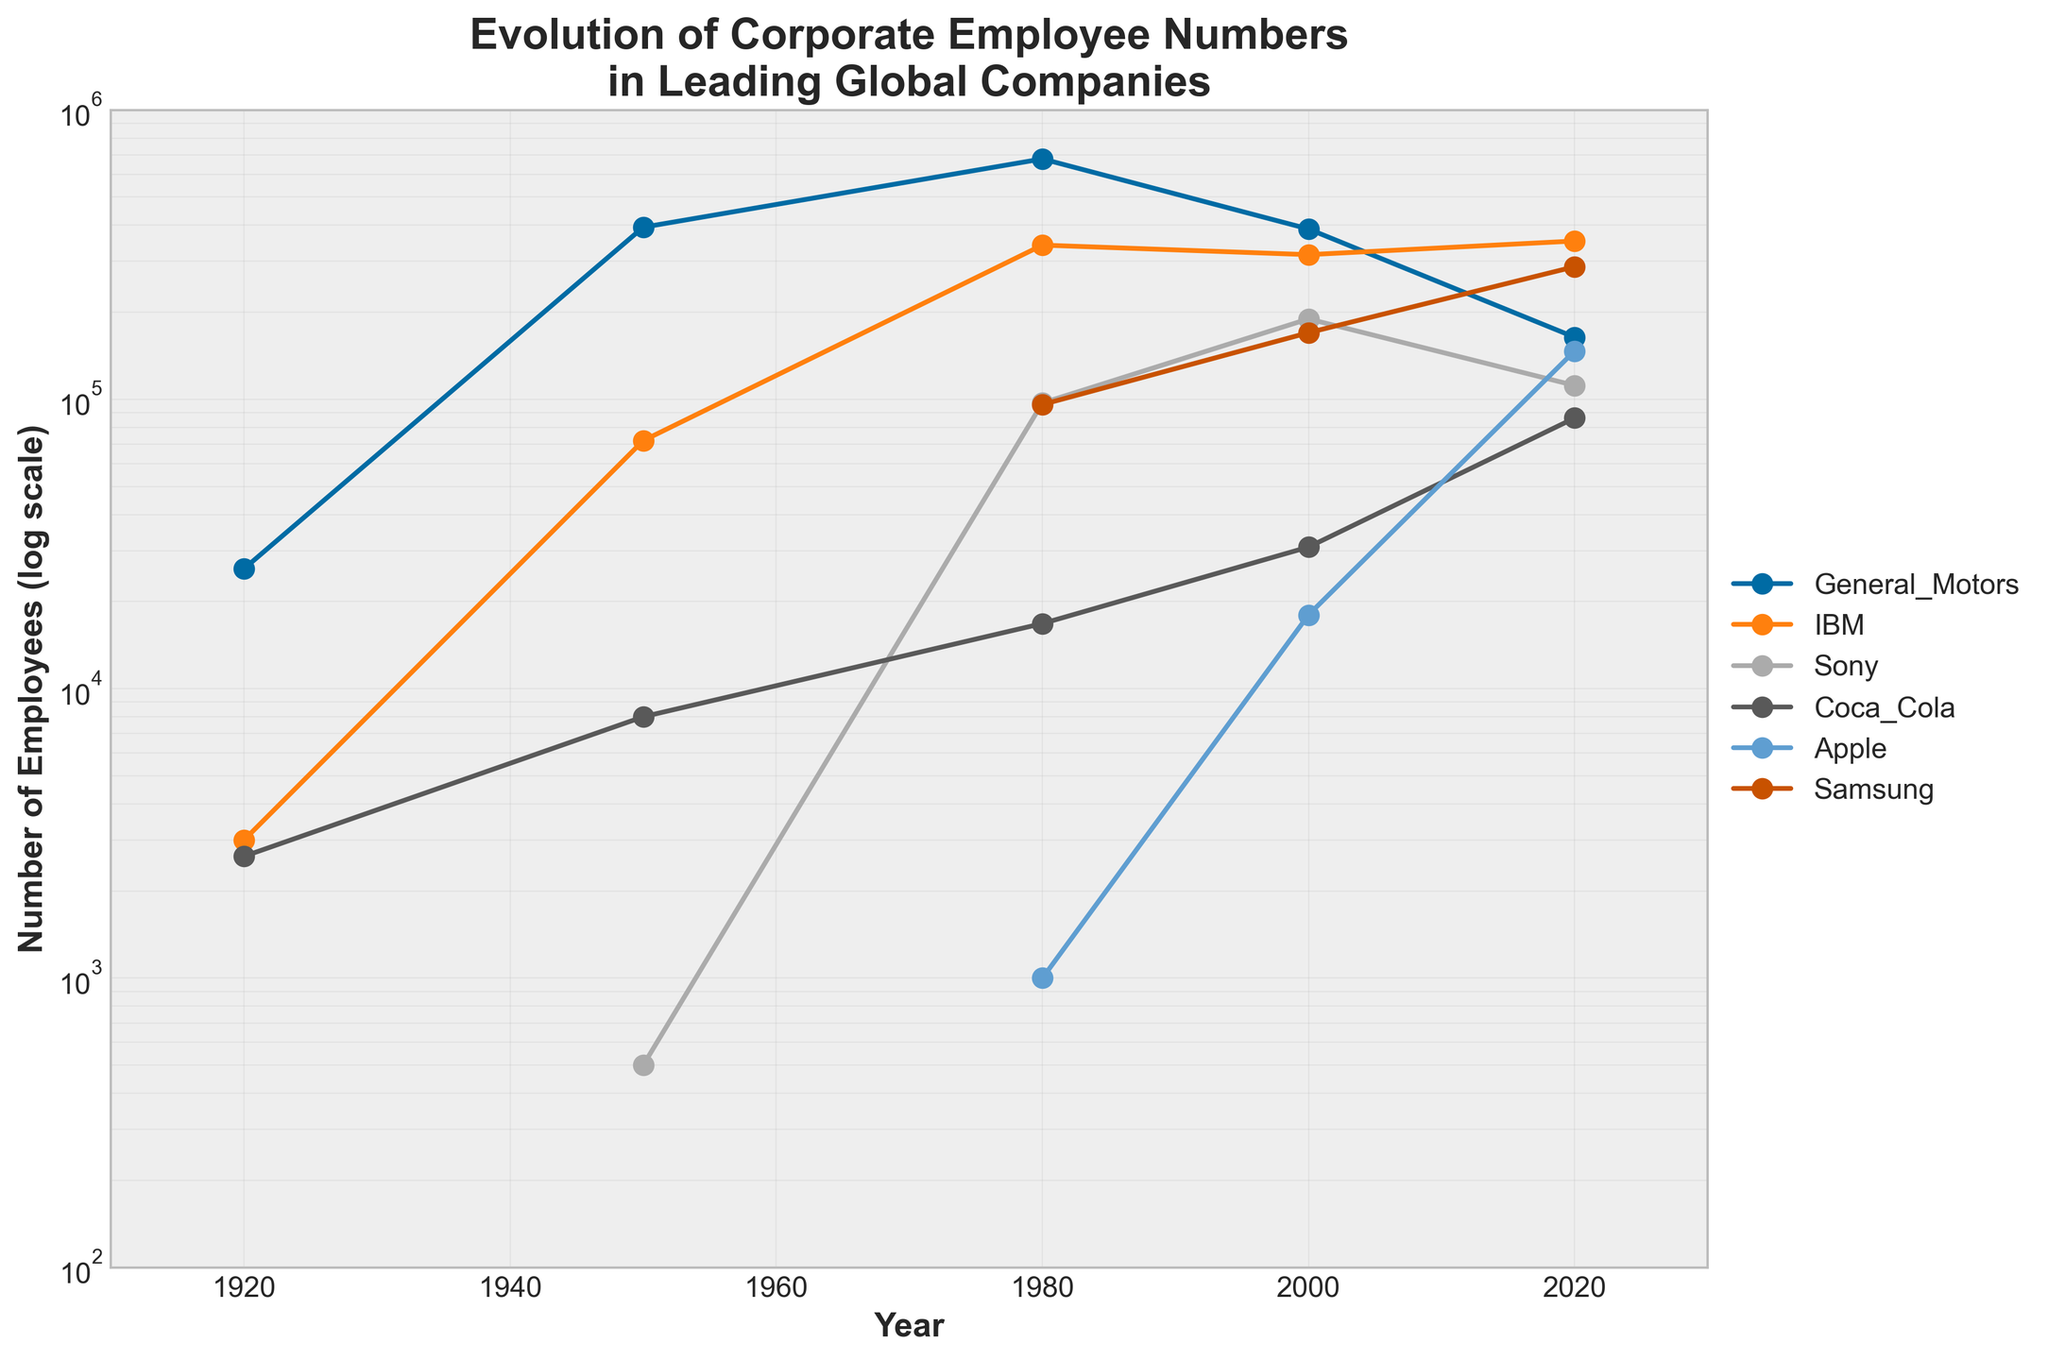How many companies are shown in the figure? By counting the different labels in the legend (like General Motors, IBM, Sony, etc.), we can identify the number of companies represented.
Answer: 6 What is the title of the figure? The title is typically located at the top of the figure and provides an overview of what the figure represents.
Answer: Evolution of Corporate Employee Numbers in Leading Global Companies What is the highest number of employees for Samsung according to the figure? We trace the trend line for Samsung and look for the highest data point. The log scale can help us identify this point by interpreting the values on the y-axis.
Answer: 287439 How many times did the number of employees at General Motors decrease from 1980 to 2020? First, find the employee numbers for both 1980 and 2020 from the trend line: 677742 (1980) and 164000 (2020). Then calculate the ratio: 677742 / 164000.
Answer: 4.13 times approximately Which company had the smallest number of employees around 1950? Locate the 1950 year mark on the x-axis and examine the y-values for each company's trend line to find the smallest one.
Answer: Sony Between Apple and IBM, which company had a larger workforce in the year 2000? Locate the year 2000 on the x-axis and compare the y-values of Apple and IBM.
Answer: IBM In which period did IBM experience the most significant increase in the number of employees? Identify the segment with the steepest slope in IBM's trend line. Check the corresponding years on the x-axis.
Answer: 1920 to 1980 What is the range of the y-axis in the figure? The range of the y-axis can be determined by looking at the smallest and largest values shown, which are indicated on the log scale.
Answer: 100 to 1,000,000 Did any company have a continuous decline in employee numbers over the last 40 years? Examine the trend lines for the last 40 years (from 1980 to 2020) to see if any company's line consistently goes downwards.
Answer: General Motors How did Coca-Cola's workforce change from 2000 to 2020? Check Coca-Cola's trend line from the year 2000 to 2020 and observe the direction and amount of change.
Answer: It increased 